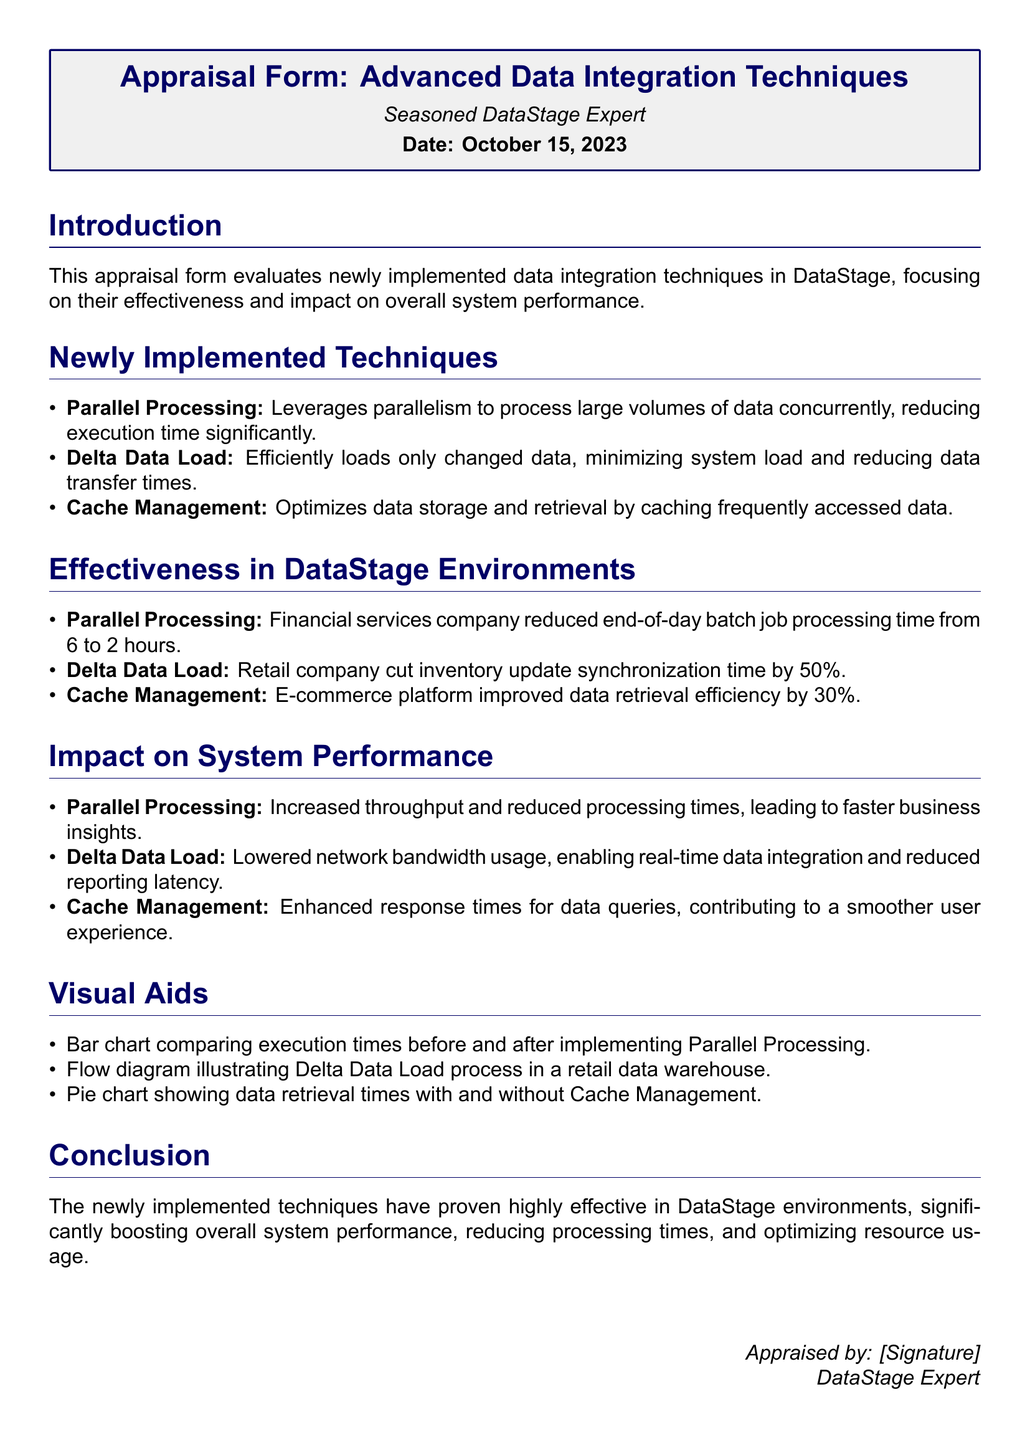What are the newly implemented techniques? The document lists three newly implemented techniques: Parallel Processing, Delta Data Load, and Cache Management.
Answer: Parallel Processing, Delta Data Load, Cache Management What percentage did the retail company cut its inventory update synchronization time by? The document states that the retail company cut inventory update synchronization time by 50%.
Answer: 50% What was the batch job processing time reduced to after implementing Parallel Processing? The financial services company reduced the end-of-day batch job processing time from 6 hours to 2 hours.
Answer: 2 hours Which technique improved data retrieval efficiency by 30 percent? The document indicates that Cache Management improved data retrieval efficiency by 30%.
Answer: Cache Management What is the overall impact of the newly implemented techniques on system performance? The document notes that they significantly boosted overall system performance, reducing processing times and optimizing resource usage.
Answer: Boosted overall system performance What is the date of the appraisal? The document specifies that the date of the appraisal is October 15, 2023.
Answer: October 15, 2023 Which company improved response times for data queries? The e-commerce platform is identified in the document as having improved response times for data queries.
Answer: E-commerce platform What visual aid illustrates the Delta Data Load process? The document mentions a flow diagram that illustrates the Delta Data Load process in a retail data warehouse.
Answer: Flow diagram What color is used for the section titles? The document states that the section titles are formatted in dark blue.
Answer: Dark blue 